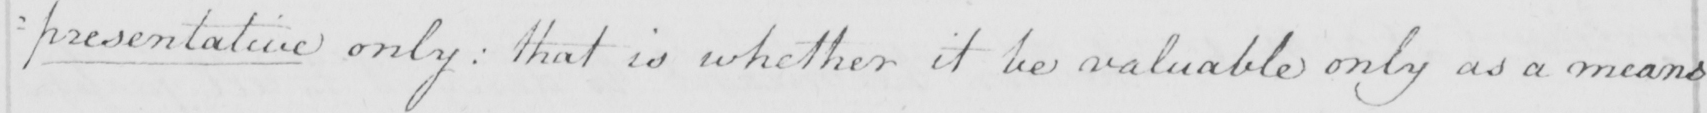What is written in this line of handwriting? presentative only :  that is whether it be valuable only as a means 